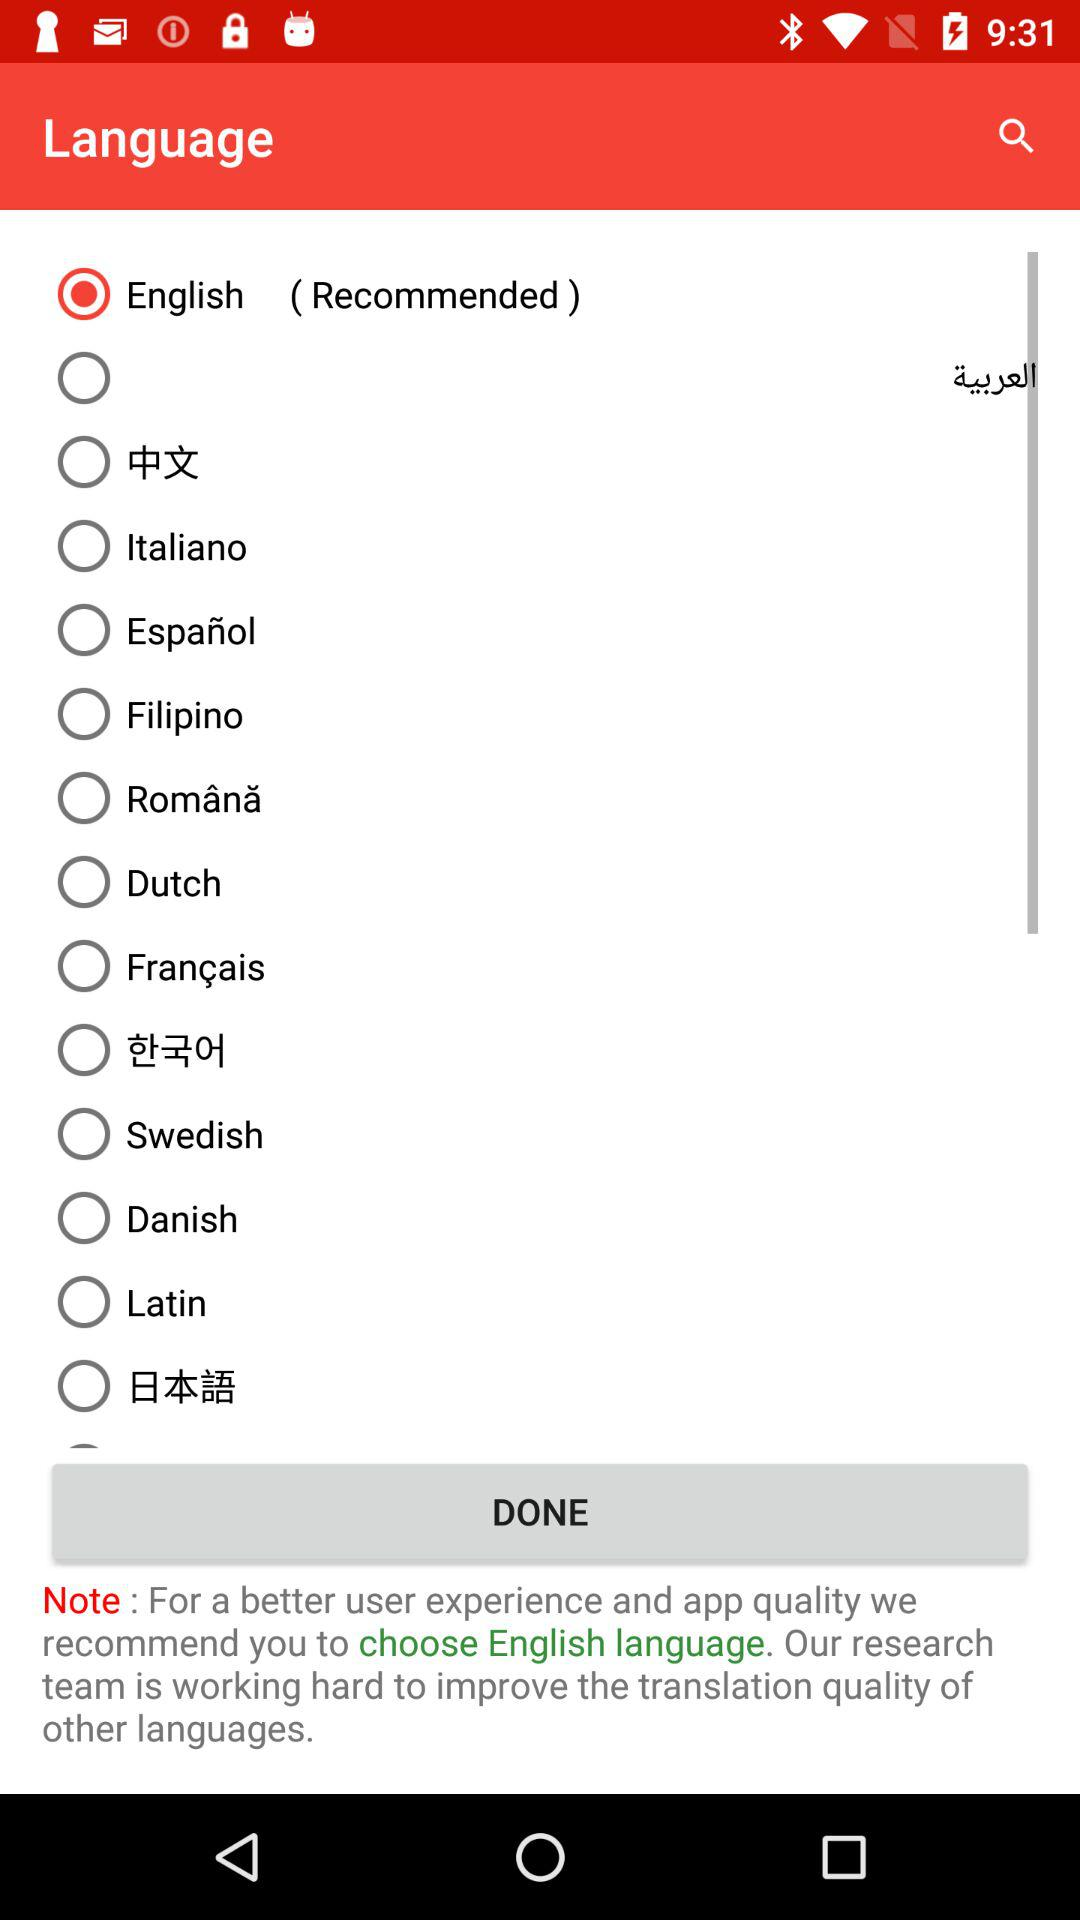What's the recommended language? The recommended language is English. 